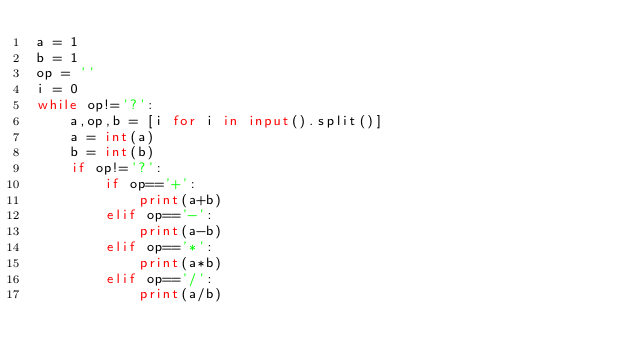<code> <loc_0><loc_0><loc_500><loc_500><_Python_>a = 1
b = 1
op = ''
i = 0
while op!='?':
	a,op,b = [i for i in input().split()]
	a = int(a)
	b = int(b)
	if op!='?':
		if op=='+':
			print(a+b)
		elif op=='-':
			print(a-b)
		elif op=='*':
			print(a*b)
		elif op=='/':
			print(a/b)</code> 